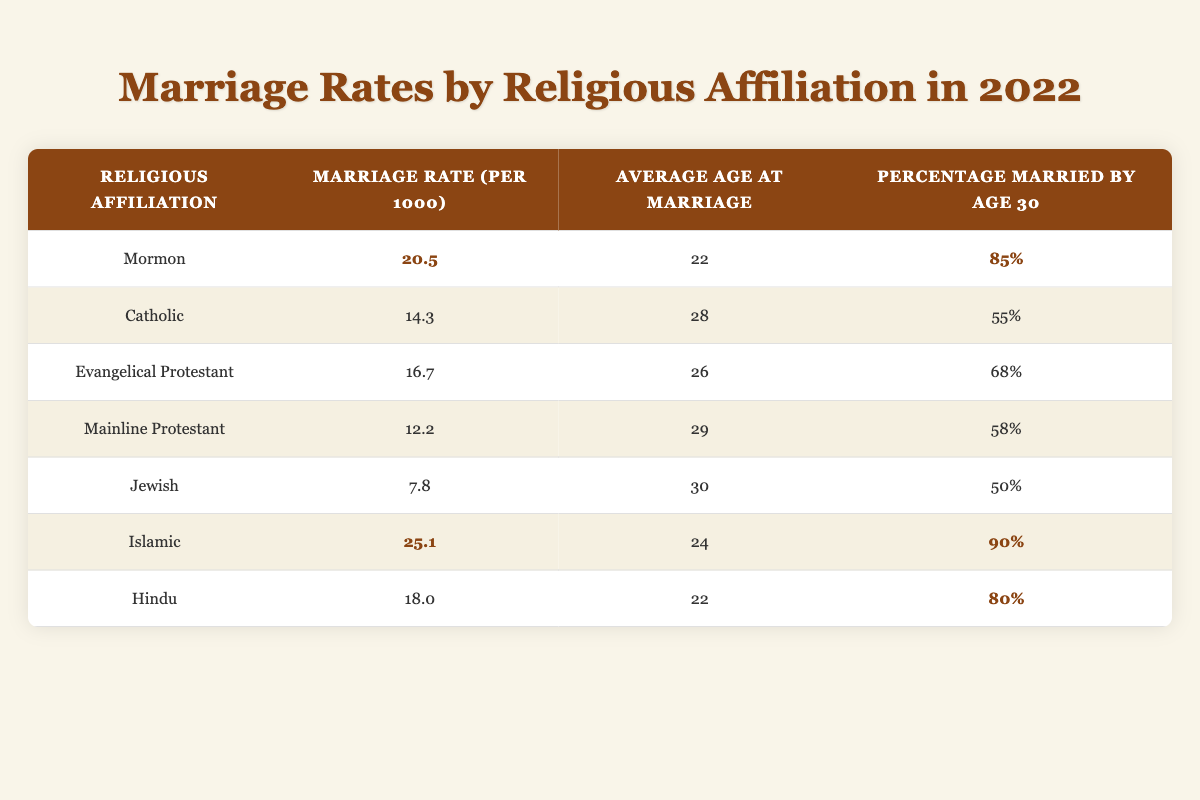What is the marriage rate for Mormons in 2022? The table shows that the marriage rate for Mormons is highlighted and is listed as 20.5 per 1000.
Answer: 20.5 Which religious affiliation has the highest percentage of individuals married by age 30? By examining the "Percentage Married by Age 30" column, Islamic has the highest percentage at 90%.
Answer: 90% What is the average age at marriage for Jewish individuals? The table indicates that the average age at marriage for the Jewish religious affiliation is 30.
Answer: 30 Is the marriage rate for Evangelical Protestants higher than that for Mainline Protestants? The table shows that Evangelical Protestants have a marriage rate of 16.7, while Mainline Protestants have a marriage rate of 12.2, confirming that Evangelical Protestants have a higher rate.
Answer: Yes What is the difference in marriage rates between Islamic and Jewish individuals? The marriage rate for Islamic individuals is 25.1, and for Jewish individuals, it is 7.8. The difference is calculated as 25.1 - 7.8 = 17.3.
Answer: 17.3 What is the average age at marriage for the top three religious affiliations by marriage rate? The top three marriage rates are 25.1 (Islamic), 20.5 (Mormon), and 18.0 (Hindu) with average ages being 24 (Islamic), 22 (Mormon), and 22 (Hindu). The average age is (24 + 22 + 22) / 3 = 22.67, which rounds to 23.
Answer: 23 What percentage of Jews are married by age 30 compared to Catholics? The table shows that 50% of Jews are married by age 30, while 55% of Catholics are married by age 30. Thus, Catholics have a higher percentage.
Answer: Catholics have a higher percentage Are the majority of Mormons married by age 30? The table indicates that 85% of Mormons are married by age 30, which is indeed a majority (over 50%).
Answer: Yes What is the average marriage rate of the four Protestant groups listed? The marriage rates for the Protestant groups are Evangelical (16.7), Mainline (12.2), and we will exclude Jewish and Islamic as they are not Protestant. The average is (16.7 + 12.2) / 2 = 14.45.
Answer: 14.45 Which religious group has the lowest marriage rate? From the table, the Jewish affiliation has the lowest marriage rate at 7.8 per 1000.
Answer: 7.8 